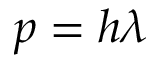<formula> <loc_0><loc_0><loc_500><loc_500>p = h \lambda</formula> 